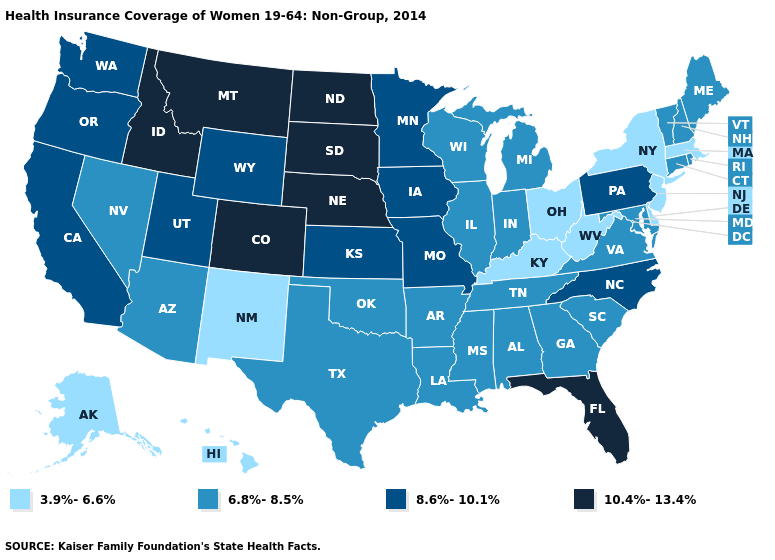What is the value of Kentucky?
Answer briefly. 3.9%-6.6%. Name the states that have a value in the range 6.8%-8.5%?
Give a very brief answer. Alabama, Arizona, Arkansas, Connecticut, Georgia, Illinois, Indiana, Louisiana, Maine, Maryland, Michigan, Mississippi, Nevada, New Hampshire, Oklahoma, Rhode Island, South Carolina, Tennessee, Texas, Vermont, Virginia, Wisconsin. What is the highest value in the USA?
Keep it brief. 10.4%-13.4%. Name the states that have a value in the range 8.6%-10.1%?
Concise answer only. California, Iowa, Kansas, Minnesota, Missouri, North Carolina, Oregon, Pennsylvania, Utah, Washington, Wyoming. Name the states that have a value in the range 10.4%-13.4%?
Short answer required. Colorado, Florida, Idaho, Montana, Nebraska, North Dakota, South Dakota. Name the states that have a value in the range 8.6%-10.1%?
Write a very short answer. California, Iowa, Kansas, Minnesota, Missouri, North Carolina, Oregon, Pennsylvania, Utah, Washington, Wyoming. What is the value of Washington?
Write a very short answer. 8.6%-10.1%. What is the value of Connecticut?
Short answer required. 6.8%-8.5%. Which states hav the highest value in the MidWest?
Concise answer only. Nebraska, North Dakota, South Dakota. Name the states that have a value in the range 3.9%-6.6%?
Answer briefly. Alaska, Delaware, Hawaii, Kentucky, Massachusetts, New Jersey, New Mexico, New York, Ohio, West Virginia. Does New York have the highest value in the USA?
Be succinct. No. What is the value of Oregon?
Quick response, please. 8.6%-10.1%. Among the states that border Massachusetts , does New York have the highest value?
Concise answer only. No. Among the states that border Minnesota , which have the lowest value?
Keep it brief. Wisconsin. 